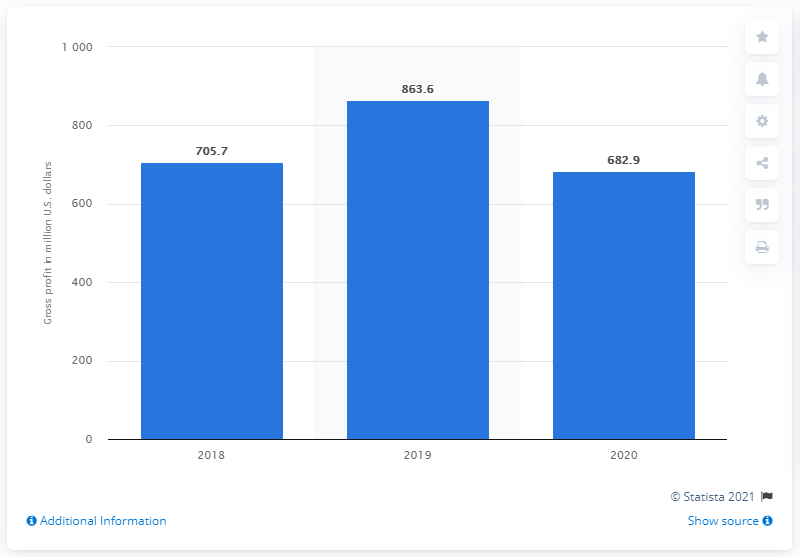Highlight a few significant elements in this photo. In 2020, Kate Spade's gross profit was 682.9 million dollars. 